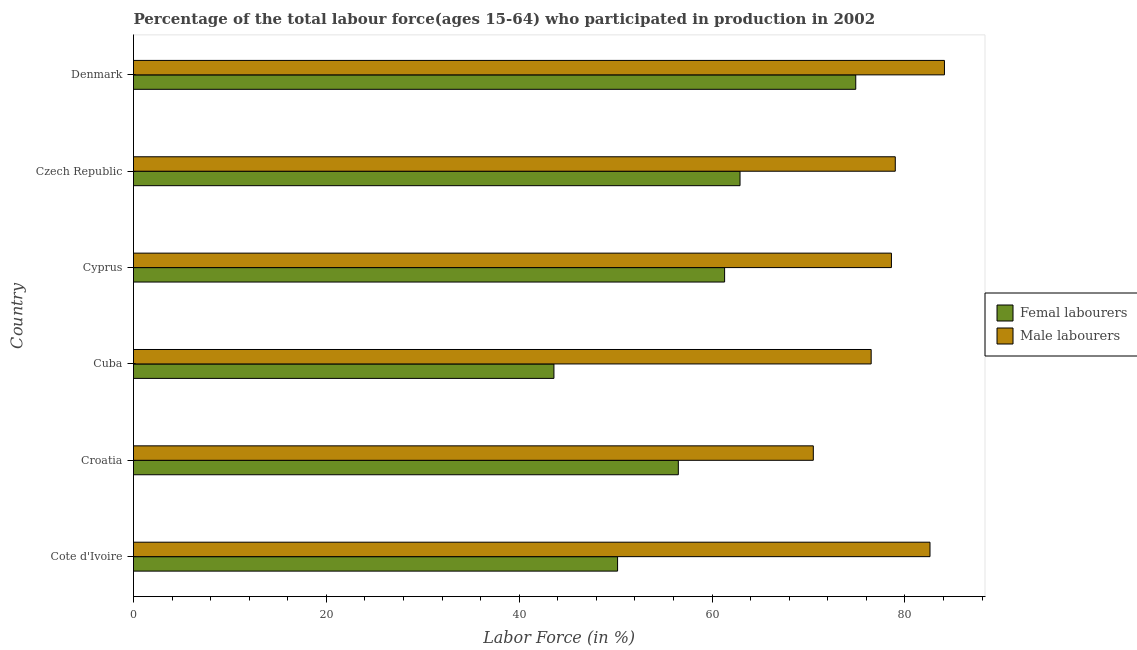How many bars are there on the 6th tick from the top?
Your response must be concise. 2. What is the label of the 1st group of bars from the top?
Make the answer very short. Denmark. In how many cases, is the number of bars for a given country not equal to the number of legend labels?
Offer a very short reply. 0. What is the percentage of male labour force in Cote d'Ivoire?
Provide a succinct answer. 82.6. Across all countries, what is the maximum percentage of male labour force?
Give a very brief answer. 84.1. Across all countries, what is the minimum percentage of male labour force?
Give a very brief answer. 70.5. In which country was the percentage of male labour force minimum?
Provide a short and direct response. Croatia. What is the total percentage of male labour force in the graph?
Provide a short and direct response. 471.3. What is the difference between the percentage of female labor force in Cote d'Ivoire and that in Czech Republic?
Offer a terse response. -12.7. What is the difference between the percentage of female labor force in Czech Republic and the percentage of male labour force in Croatia?
Your answer should be compact. -7.6. What is the average percentage of male labour force per country?
Your response must be concise. 78.55. In how many countries, is the percentage of male labour force greater than 68 %?
Provide a short and direct response. 6. What is the ratio of the percentage of male labour force in Cyprus to that in Czech Republic?
Offer a very short reply. 0.99. Is the percentage of male labour force in Cuba less than that in Cyprus?
Give a very brief answer. Yes. What is the difference between the highest and the second highest percentage of male labour force?
Your response must be concise. 1.5. In how many countries, is the percentage of male labour force greater than the average percentage of male labour force taken over all countries?
Provide a short and direct response. 4. Is the sum of the percentage of female labor force in Cyprus and Denmark greater than the maximum percentage of male labour force across all countries?
Offer a very short reply. Yes. What does the 2nd bar from the top in Cyprus represents?
Your response must be concise. Femal labourers. What does the 2nd bar from the bottom in Czech Republic represents?
Provide a succinct answer. Male labourers. Are all the bars in the graph horizontal?
Your answer should be very brief. Yes. How are the legend labels stacked?
Keep it short and to the point. Vertical. What is the title of the graph?
Your answer should be very brief. Percentage of the total labour force(ages 15-64) who participated in production in 2002. What is the Labor Force (in %) in Femal labourers in Cote d'Ivoire?
Your answer should be compact. 50.2. What is the Labor Force (in %) of Male labourers in Cote d'Ivoire?
Make the answer very short. 82.6. What is the Labor Force (in %) in Femal labourers in Croatia?
Your answer should be compact. 56.5. What is the Labor Force (in %) in Male labourers in Croatia?
Your answer should be compact. 70.5. What is the Labor Force (in %) in Femal labourers in Cuba?
Give a very brief answer. 43.6. What is the Labor Force (in %) of Male labourers in Cuba?
Your answer should be very brief. 76.5. What is the Labor Force (in %) of Femal labourers in Cyprus?
Your answer should be very brief. 61.3. What is the Labor Force (in %) of Male labourers in Cyprus?
Your answer should be compact. 78.6. What is the Labor Force (in %) of Femal labourers in Czech Republic?
Provide a succinct answer. 62.9. What is the Labor Force (in %) of Male labourers in Czech Republic?
Provide a succinct answer. 79. What is the Labor Force (in %) in Femal labourers in Denmark?
Keep it short and to the point. 74.9. What is the Labor Force (in %) of Male labourers in Denmark?
Your response must be concise. 84.1. Across all countries, what is the maximum Labor Force (in %) of Femal labourers?
Your answer should be compact. 74.9. Across all countries, what is the maximum Labor Force (in %) in Male labourers?
Ensure brevity in your answer.  84.1. Across all countries, what is the minimum Labor Force (in %) of Femal labourers?
Give a very brief answer. 43.6. Across all countries, what is the minimum Labor Force (in %) in Male labourers?
Keep it short and to the point. 70.5. What is the total Labor Force (in %) of Femal labourers in the graph?
Keep it short and to the point. 349.4. What is the total Labor Force (in %) of Male labourers in the graph?
Provide a short and direct response. 471.3. What is the difference between the Labor Force (in %) in Femal labourers in Cote d'Ivoire and that in Cyprus?
Ensure brevity in your answer.  -11.1. What is the difference between the Labor Force (in %) of Male labourers in Cote d'Ivoire and that in Czech Republic?
Keep it short and to the point. 3.6. What is the difference between the Labor Force (in %) of Femal labourers in Cote d'Ivoire and that in Denmark?
Offer a terse response. -24.7. What is the difference between the Labor Force (in %) of Male labourers in Cote d'Ivoire and that in Denmark?
Provide a succinct answer. -1.5. What is the difference between the Labor Force (in %) in Femal labourers in Croatia and that in Cuba?
Ensure brevity in your answer.  12.9. What is the difference between the Labor Force (in %) of Male labourers in Croatia and that in Cuba?
Provide a short and direct response. -6. What is the difference between the Labor Force (in %) in Femal labourers in Croatia and that in Cyprus?
Provide a short and direct response. -4.8. What is the difference between the Labor Force (in %) of Male labourers in Croatia and that in Cyprus?
Offer a terse response. -8.1. What is the difference between the Labor Force (in %) of Femal labourers in Croatia and that in Denmark?
Provide a short and direct response. -18.4. What is the difference between the Labor Force (in %) of Male labourers in Croatia and that in Denmark?
Provide a succinct answer. -13.6. What is the difference between the Labor Force (in %) in Femal labourers in Cuba and that in Cyprus?
Ensure brevity in your answer.  -17.7. What is the difference between the Labor Force (in %) of Femal labourers in Cuba and that in Czech Republic?
Keep it short and to the point. -19.3. What is the difference between the Labor Force (in %) of Male labourers in Cuba and that in Czech Republic?
Give a very brief answer. -2.5. What is the difference between the Labor Force (in %) in Femal labourers in Cuba and that in Denmark?
Give a very brief answer. -31.3. What is the difference between the Labor Force (in %) of Male labourers in Cuba and that in Denmark?
Offer a very short reply. -7.6. What is the difference between the Labor Force (in %) of Femal labourers in Cyprus and that in Denmark?
Provide a succinct answer. -13.6. What is the difference between the Labor Force (in %) of Male labourers in Cyprus and that in Denmark?
Keep it short and to the point. -5.5. What is the difference between the Labor Force (in %) of Femal labourers in Czech Republic and that in Denmark?
Offer a very short reply. -12. What is the difference between the Labor Force (in %) in Male labourers in Czech Republic and that in Denmark?
Make the answer very short. -5.1. What is the difference between the Labor Force (in %) in Femal labourers in Cote d'Ivoire and the Labor Force (in %) in Male labourers in Croatia?
Make the answer very short. -20.3. What is the difference between the Labor Force (in %) in Femal labourers in Cote d'Ivoire and the Labor Force (in %) in Male labourers in Cuba?
Your answer should be compact. -26.3. What is the difference between the Labor Force (in %) in Femal labourers in Cote d'Ivoire and the Labor Force (in %) in Male labourers in Cyprus?
Provide a succinct answer. -28.4. What is the difference between the Labor Force (in %) in Femal labourers in Cote d'Ivoire and the Labor Force (in %) in Male labourers in Czech Republic?
Keep it short and to the point. -28.8. What is the difference between the Labor Force (in %) in Femal labourers in Cote d'Ivoire and the Labor Force (in %) in Male labourers in Denmark?
Provide a succinct answer. -33.9. What is the difference between the Labor Force (in %) in Femal labourers in Croatia and the Labor Force (in %) in Male labourers in Cuba?
Provide a short and direct response. -20. What is the difference between the Labor Force (in %) of Femal labourers in Croatia and the Labor Force (in %) of Male labourers in Cyprus?
Offer a terse response. -22.1. What is the difference between the Labor Force (in %) of Femal labourers in Croatia and the Labor Force (in %) of Male labourers in Czech Republic?
Your response must be concise. -22.5. What is the difference between the Labor Force (in %) in Femal labourers in Croatia and the Labor Force (in %) in Male labourers in Denmark?
Provide a succinct answer. -27.6. What is the difference between the Labor Force (in %) of Femal labourers in Cuba and the Labor Force (in %) of Male labourers in Cyprus?
Your answer should be compact. -35. What is the difference between the Labor Force (in %) in Femal labourers in Cuba and the Labor Force (in %) in Male labourers in Czech Republic?
Your response must be concise. -35.4. What is the difference between the Labor Force (in %) in Femal labourers in Cuba and the Labor Force (in %) in Male labourers in Denmark?
Your answer should be compact. -40.5. What is the difference between the Labor Force (in %) in Femal labourers in Cyprus and the Labor Force (in %) in Male labourers in Czech Republic?
Your answer should be compact. -17.7. What is the difference between the Labor Force (in %) of Femal labourers in Cyprus and the Labor Force (in %) of Male labourers in Denmark?
Keep it short and to the point. -22.8. What is the difference between the Labor Force (in %) of Femal labourers in Czech Republic and the Labor Force (in %) of Male labourers in Denmark?
Keep it short and to the point. -21.2. What is the average Labor Force (in %) of Femal labourers per country?
Keep it short and to the point. 58.23. What is the average Labor Force (in %) of Male labourers per country?
Provide a short and direct response. 78.55. What is the difference between the Labor Force (in %) of Femal labourers and Labor Force (in %) of Male labourers in Cote d'Ivoire?
Offer a terse response. -32.4. What is the difference between the Labor Force (in %) of Femal labourers and Labor Force (in %) of Male labourers in Cuba?
Provide a succinct answer. -32.9. What is the difference between the Labor Force (in %) in Femal labourers and Labor Force (in %) in Male labourers in Cyprus?
Your answer should be compact. -17.3. What is the difference between the Labor Force (in %) in Femal labourers and Labor Force (in %) in Male labourers in Czech Republic?
Your answer should be very brief. -16.1. What is the ratio of the Labor Force (in %) of Femal labourers in Cote d'Ivoire to that in Croatia?
Ensure brevity in your answer.  0.89. What is the ratio of the Labor Force (in %) of Male labourers in Cote d'Ivoire to that in Croatia?
Your response must be concise. 1.17. What is the ratio of the Labor Force (in %) of Femal labourers in Cote d'Ivoire to that in Cuba?
Provide a short and direct response. 1.15. What is the ratio of the Labor Force (in %) of Male labourers in Cote d'Ivoire to that in Cuba?
Provide a succinct answer. 1.08. What is the ratio of the Labor Force (in %) of Femal labourers in Cote d'Ivoire to that in Cyprus?
Provide a succinct answer. 0.82. What is the ratio of the Labor Force (in %) of Male labourers in Cote d'Ivoire to that in Cyprus?
Your answer should be compact. 1.05. What is the ratio of the Labor Force (in %) in Femal labourers in Cote d'Ivoire to that in Czech Republic?
Your answer should be compact. 0.8. What is the ratio of the Labor Force (in %) in Male labourers in Cote d'Ivoire to that in Czech Republic?
Make the answer very short. 1.05. What is the ratio of the Labor Force (in %) of Femal labourers in Cote d'Ivoire to that in Denmark?
Offer a terse response. 0.67. What is the ratio of the Labor Force (in %) of Male labourers in Cote d'Ivoire to that in Denmark?
Ensure brevity in your answer.  0.98. What is the ratio of the Labor Force (in %) of Femal labourers in Croatia to that in Cuba?
Ensure brevity in your answer.  1.3. What is the ratio of the Labor Force (in %) of Male labourers in Croatia to that in Cuba?
Provide a succinct answer. 0.92. What is the ratio of the Labor Force (in %) of Femal labourers in Croatia to that in Cyprus?
Offer a terse response. 0.92. What is the ratio of the Labor Force (in %) in Male labourers in Croatia to that in Cyprus?
Your answer should be compact. 0.9. What is the ratio of the Labor Force (in %) in Femal labourers in Croatia to that in Czech Republic?
Ensure brevity in your answer.  0.9. What is the ratio of the Labor Force (in %) in Male labourers in Croatia to that in Czech Republic?
Make the answer very short. 0.89. What is the ratio of the Labor Force (in %) in Femal labourers in Croatia to that in Denmark?
Make the answer very short. 0.75. What is the ratio of the Labor Force (in %) in Male labourers in Croatia to that in Denmark?
Ensure brevity in your answer.  0.84. What is the ratio of the Labor Force (in %) in Femal labourers in Cuba to that in Cyprus?
Provide a short and direct response. 0.71. What is the ratio of the Labor Force (in %) of Male labourers in Cuba to that in Cyprus?
Offer a very short reply. 0.97. What is the ratio of the Labor Force (in %) in Femal labourers in Cuba to that in Czech Republic?
Keep it short and to the point. 0.69. What is the ratio of the Labor Force (in %) of Male labourers in Cuba to that in Czech Republic?
Provide a short and direct response. 0.97. What is the ratio of the Labor Force (in %) of Femal labourers in Cuba to that in Denmark?
Your response must be concise. 0.58. What is the ratio of the Labor Force (in %) of Male labourers in Cuba to that in Denmark?
Provide a short and direct response. 0.91. What is the ratio of the Labor Force (in %) in Femal labourers in Cyprus to that in Czech Republic?
Your answer should be very brief. 0.97. What is the ratio of the Labor Force (in %) in Femal labourers in Cyprus to that in Denmark?
Provide a short and direct response. 0.82. What is the ratio of the Labor Force (in %) of Male labourers in Cyprus to that in Denmark?
Offer a terse response. 0.93. What is the ratio of the Labor Force (in %) of Femal labourers in Czech Republic to that in Denmark?
Ensure brevity in your answer.  0.84. What is the ratio of the Labor Force (in %) in Male labourers in Czech Republic to that in Denmark?
Keep it short and to the point. 0.94. What is the difference between the highest and the lowest Labor Force (in %) of Femal labourers?
Offer a very short reply. 31.3. What is the difference between the highest and the lowest Labor Force (in %) of Male labourers?
Your response must be concise. 13.6. 